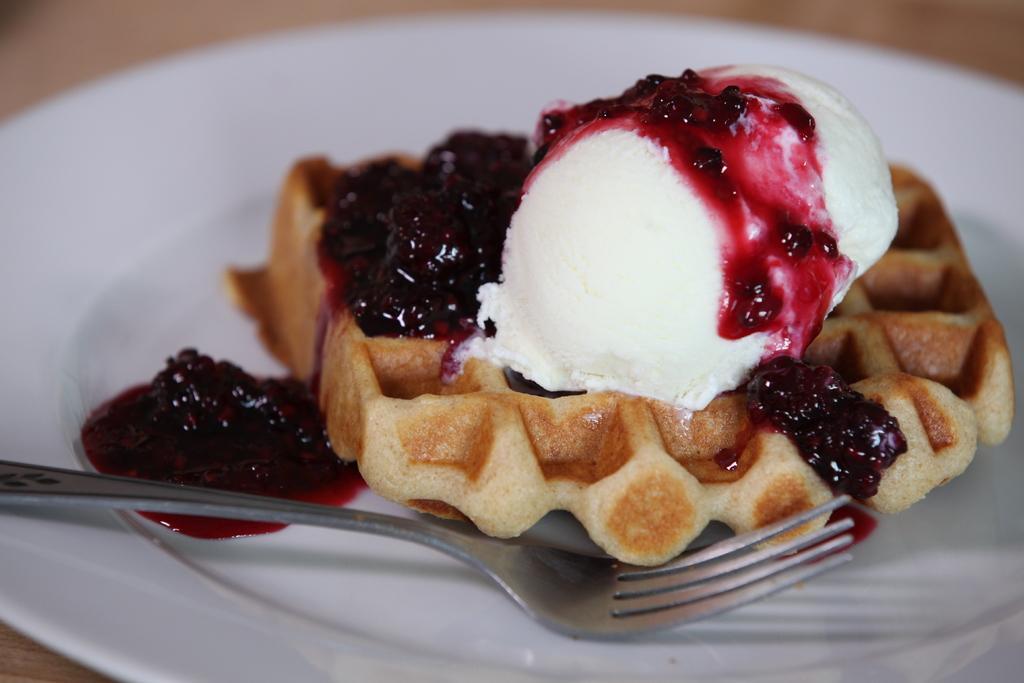Please provide a concise description of this image. In this picture we can see a table. On the table we can see a plate which contains food with fork. 